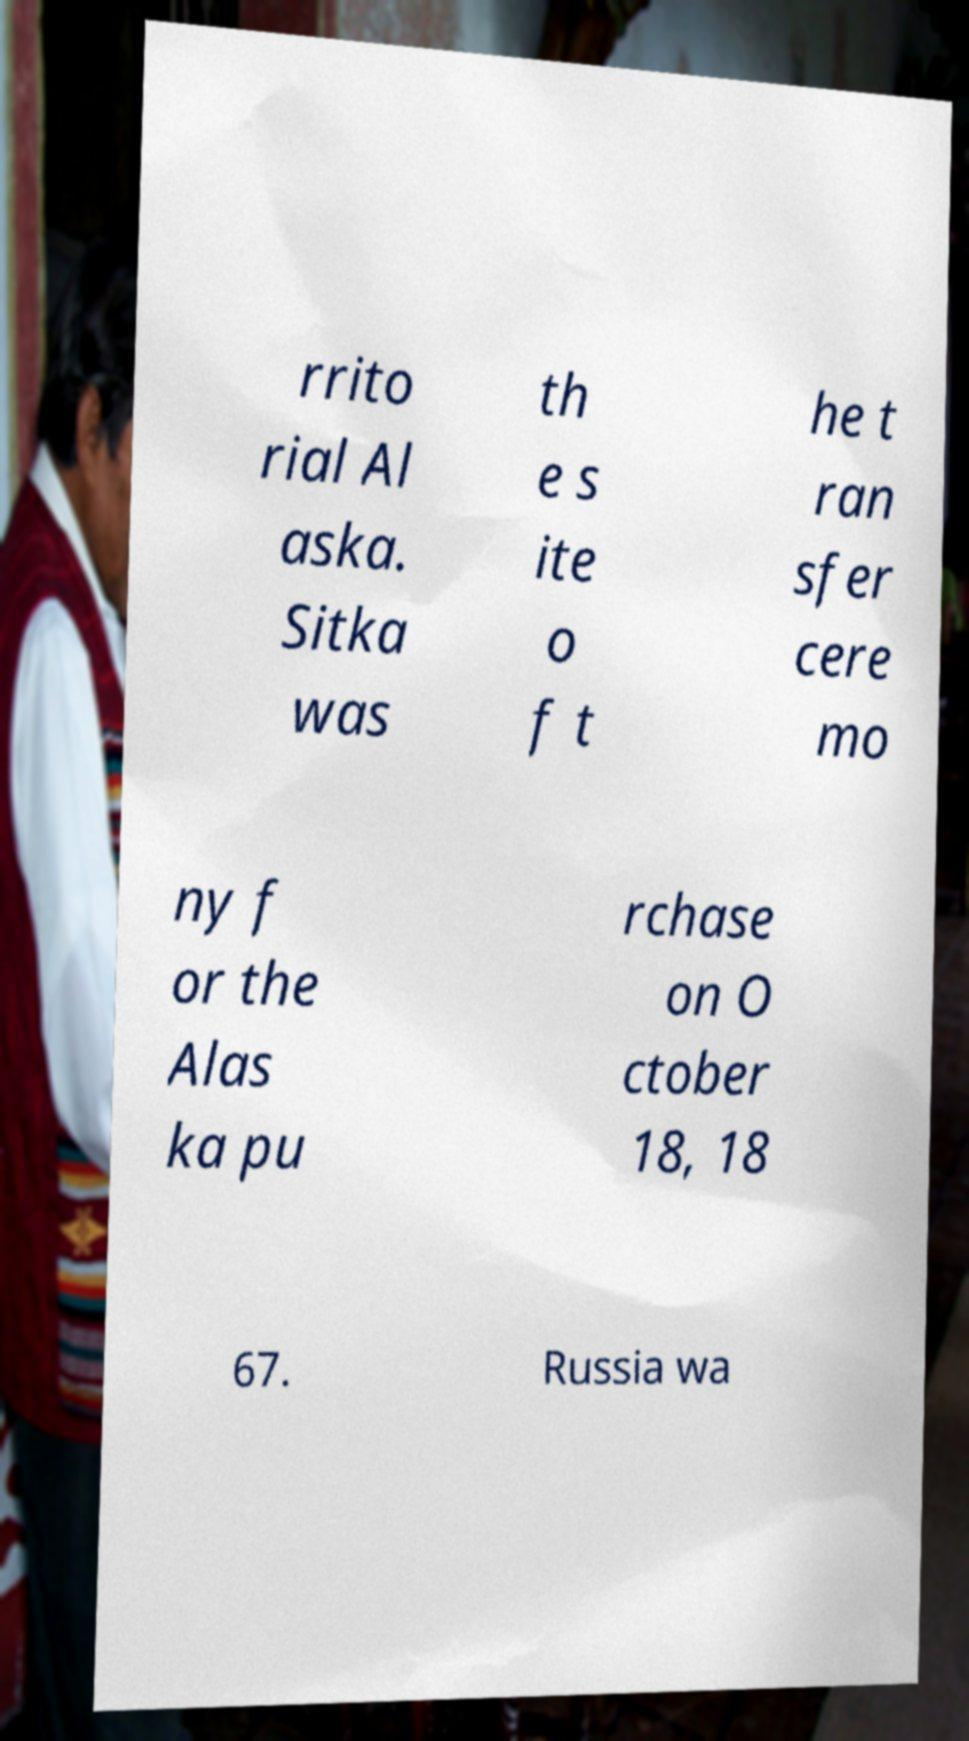For documentation purposes, I need the text within this image transcribed. Could you provide that? rrito rial Al aska. Sitka was th e s ite o f t he t ran sfer cere mo ny f or the Alas ka pu rchase on O ctober 18, 18 67. Russia wa 